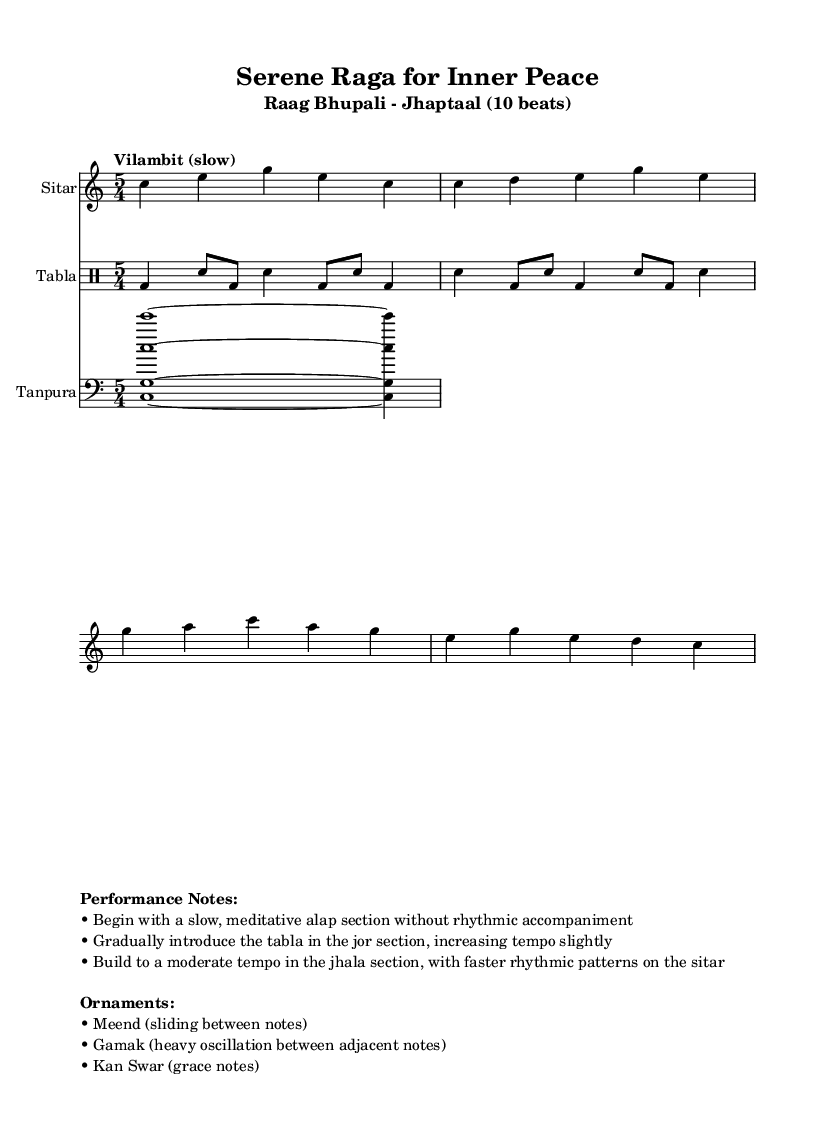What is the key signature of this music? The key signature is C major, which has no sharps or flats indicated in the sheet music.
Answer: C major What is the time signature of the piece? The time signature shown in the music is 5/4 time, which indicates there are five beats per measure.
Answer: 5/4 What is the tempo marking for this piece? The tempo marking provided indicates that the music should be played "Vilambit (slow)," which sets the pace for the performance.
Answer: Vilambit How many beats are in each measure for the tabla pattern? The tabla pattern follows the same 5/4 time signature as the rest of the piece, confirming that there are five beats in each measure.
Answer: 5 What type of music is represented in this sheet? This piece represents traditional Indian classical music, specifically intended for meditation and stress relief, as echoed in the title and performance notes.
Answer: Traditional Indian classical music Name an ornament used in the performance of this piece. The performance notes mention three ornaments, one of which is "Meend," which refers to the sliding between notes characteristic of Indian classical music.
Answer: Meend What rhythmic section does the tabla introduce? The tabla introduces rhythm in the "jor" section, marking a transition from the slow, meditative alap without rhythm.
Answer: Jor 